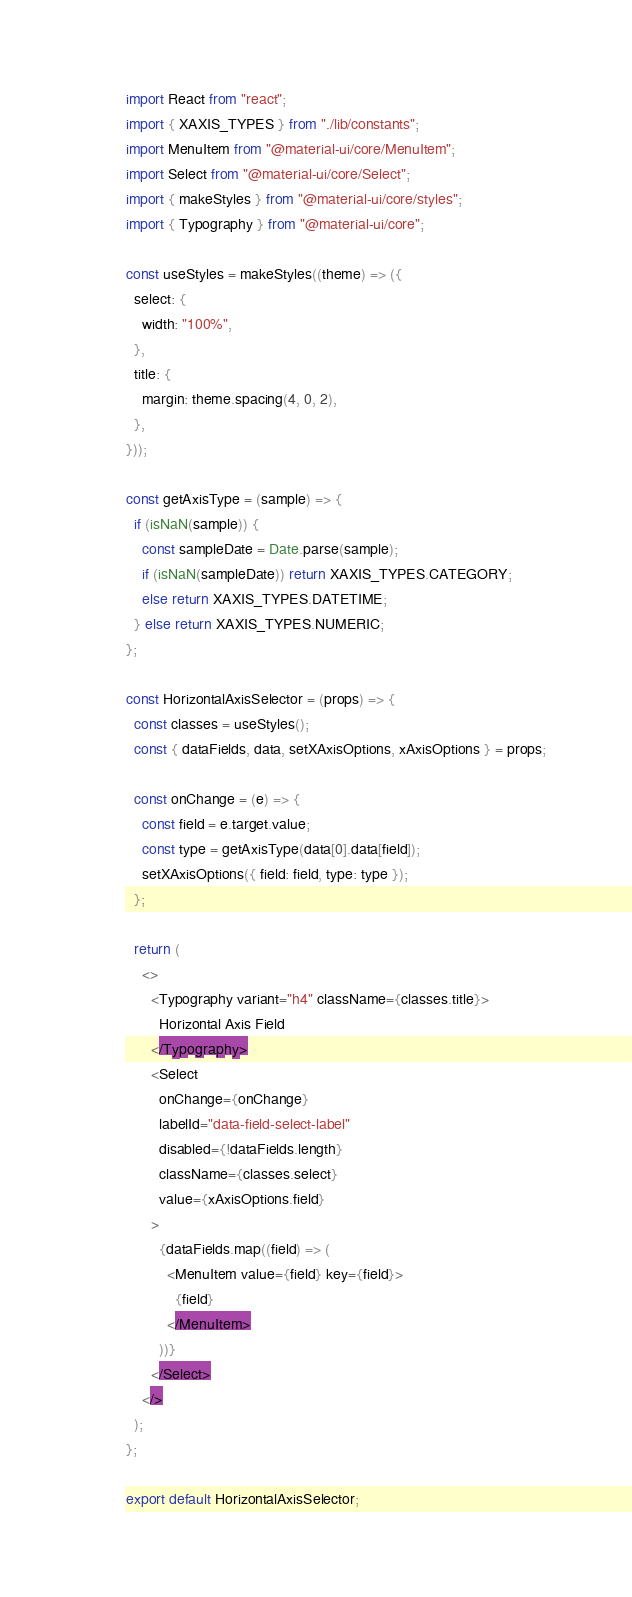<code> <loc_0><loc_0><loc_500><loc_500><_JavaScript_>import React from "react";
import { XAXIS_TYPES } from "./lib/constants";
import MenuItem from "@material-ui/core/MenuItem";
import Select from "@material-ui/core/Select";
import { makeStyles } from "@material-ui/core/styles";
import { Typography } from "@material-ui/core";

const useStyles = makeStyles((theme) => ({
  select: {
    width: "100%",
  },
  title: {
    margin: theme.spacing(4, 0, 2),
  },
}));

const getAxisType = (sample) => {
  if (isNaN(sample)) {
    const sampleDate = Date.parse(sample);
    if (isNaN(sampleDate)) return XAXIS_TYPES.CATEGORY;
    else return XAXIS_TYPES.DATETIME;
  } else return XAXIS_TYPES.NUMERIC;
};

const HorizontalAxisSelector = (props) => {
  const classes = useStyles();
  const { dataFields, data, setXAxisOptions, xAxisOptions } = props;

  const onChange = (e) => {
    const field = e.target.value;
    const type = getAxisType(data[0].data[field]);
    setXAxisOptions({ field: field, type: type });
  };

  return (
    <>
      <Typography variant="h4" className={classes.title}>
        Horizontal Axis Field
      </Typography>
      <Select
        onChange={onChange}
        labelId="data-field-select-label"
        disabled={!dataFields.length}
        className={classes.select}
        value={xAxisOptions.field}
      >
        {dataFields.map((field) => (
          <MenuItem value={field} key={field}>
            {field}
          </MenuItem>
        ))}
      </Select>
    </>
  );
};

export default HorizontalAxisSelector;
</code> 